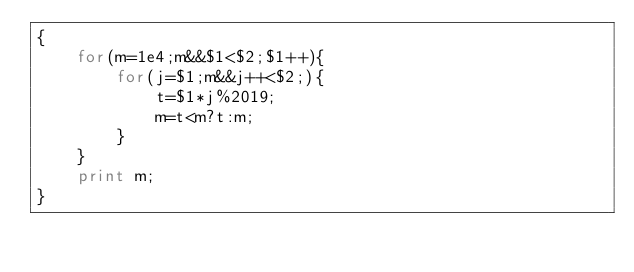Convert code to text. <code><loc_0><loc_0><loc_500><loc_500><_Awk_>{
    for(m=1e4;m&&$1<$2;$1++){
        for(j=$1;m&&j++<$2;){
            t=$1*j%2019;
            m=t<m?t:m;
        }
    }
    print m;
}</code> 